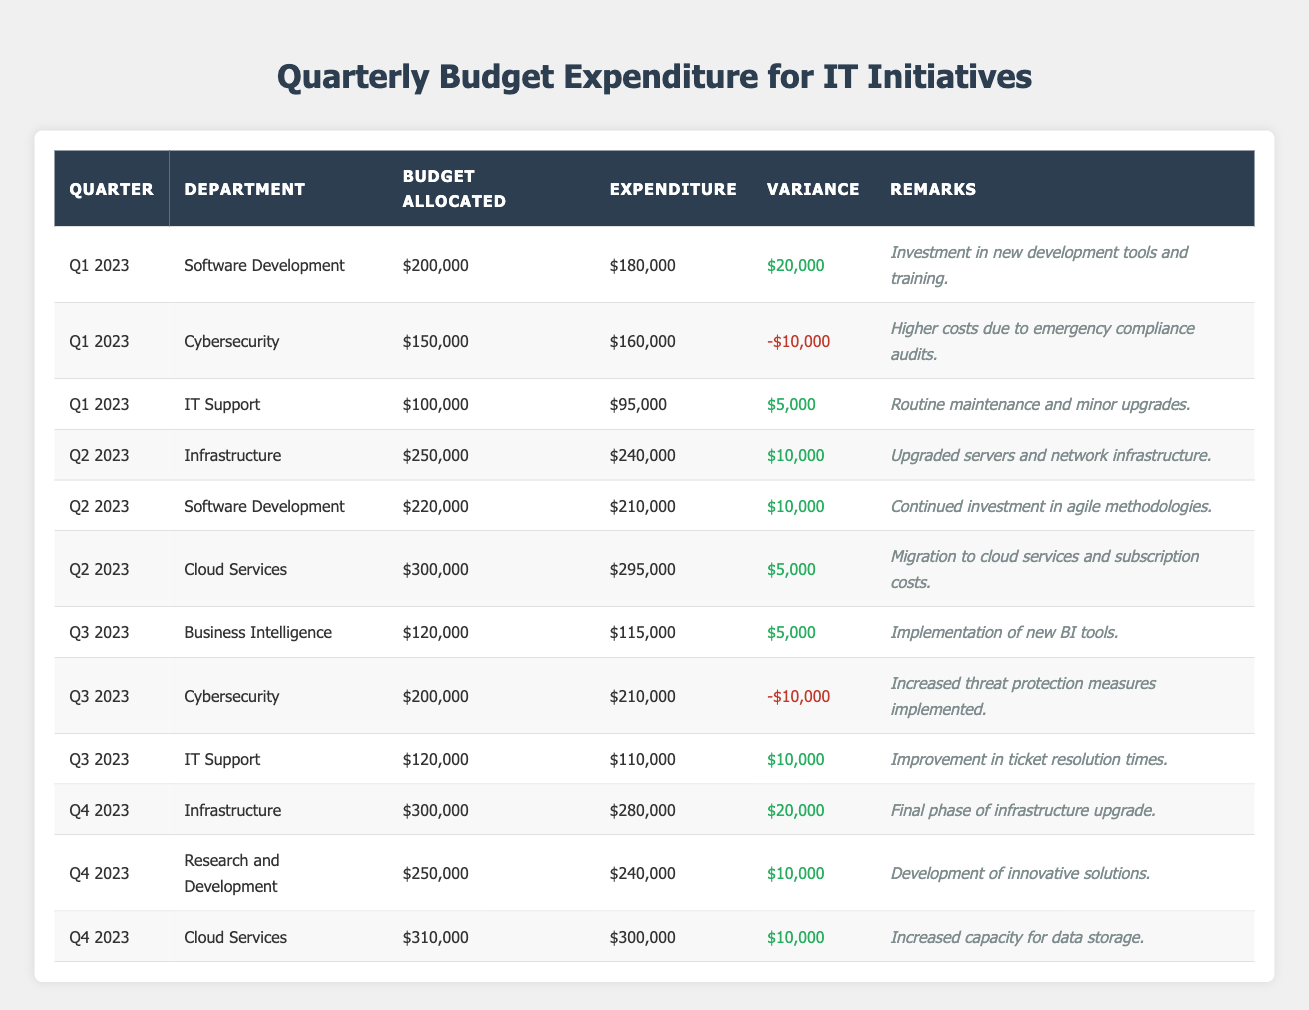What was the expenditure for the Cybersecurity department in Q1 2023? The table shows that the expenditure for the Cybersecurity department in Q1 2023 is $160,000.
Answer: $160,000 Which department had the highest budget allocated in Q2 2023? In Q2 2023, the Cloud Services department had the highest budget allocated, which was $300,000.
Answer: Cloud Services What is the variance for IT Support in Q3 2023? The variance for IT Support in Q3 2023 is $10,000, as shown in the table.
Answer: $10,000 Did the Software Development department go over budget in any quarter? Yes, the Software Development department went over budget in Q3 2023, with an expenditure of $210,000 against a budget of $200,000.
Answer: Yes What is the total budget allocated to the Infrastructure department across all quarters? The total budget allocated to the Infrastructure department is $250,000 (Q2 2023) + $300,000 (Q4 2023) = $550,000.
Answer: $550,000 Which quarter had the highest expenditure overall? The table shows that Q3 2023 had the highest total expenditure, summing up to $210,000 (Cybersecurity) + $115,000 (Business Intelligence) + $110,000 (IT Support) = $435,000.
Answer: Q3 2023 What is the average variance for all departments in Q1 2023? The variances in Q1 2023 are $20,000 (Software Development), -$10,000 (Cybersecurity), and $5,000 (IT Support), summing to $15,000. Therefore, the average variance is $15,000 / 3 = $5,000.
Answer: $5,000 Which department had the largest positive variance in Q4 2023? In Q4 2023, the Infrastructure department had the largest positive variance of $20,000, compared to $10,000 from Cloud Services and Research and Development.
Answer: Infrastructure How much did the Cloud Services department spend in total across all quarters? The Cloud Services department spent $295,000 (Q2 2023) and $300,000 (Q4 2023), totaling $595,000.
Answer: $595,000 In how many quarters did the IT Support department have a positive variance? The IT Support department had a positive variance in Q1 2023 ($5,000), Q2 2023 ($10,000), and Q3 2023 ($10,000), totaling 3 quarters.
Answer: 3 quarters 